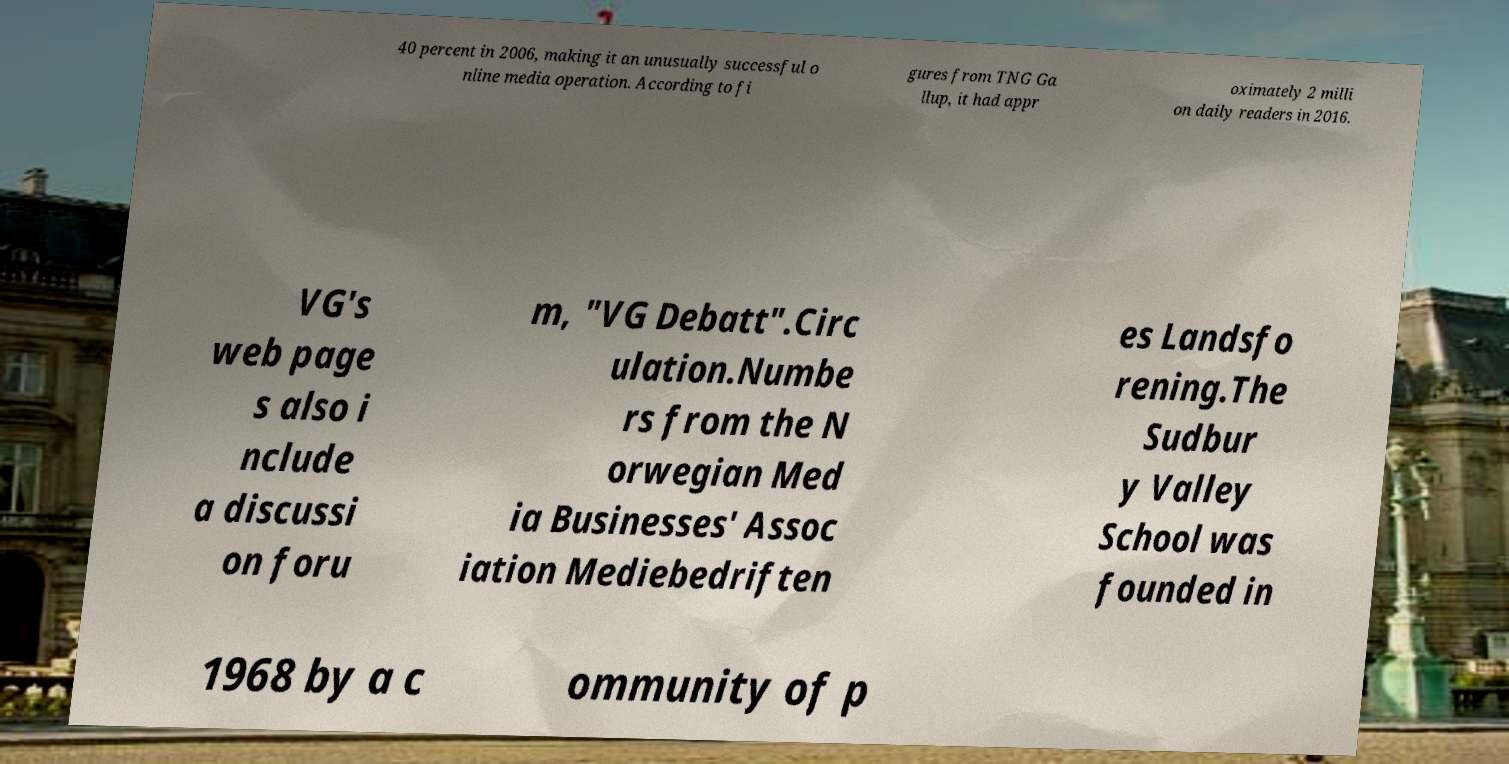Can you accurately transcribe the text from the provided image for me? 40 percent in 2006, making it an unusually successful o nline media operation. According to fi gures from TNG Ga llup, it had appr oximately 2 milli on daily readers in 2016. VG's web page s also i nclude a discussi on foru m, "VG Debatt".Circ ulation.Numbe rs from the N orwegian Med ia Businesses' Assoc iation Mediebedriften es Landsfo rening.The Sudbur y Valley School was founded in 1968 by a c ommunity of p 